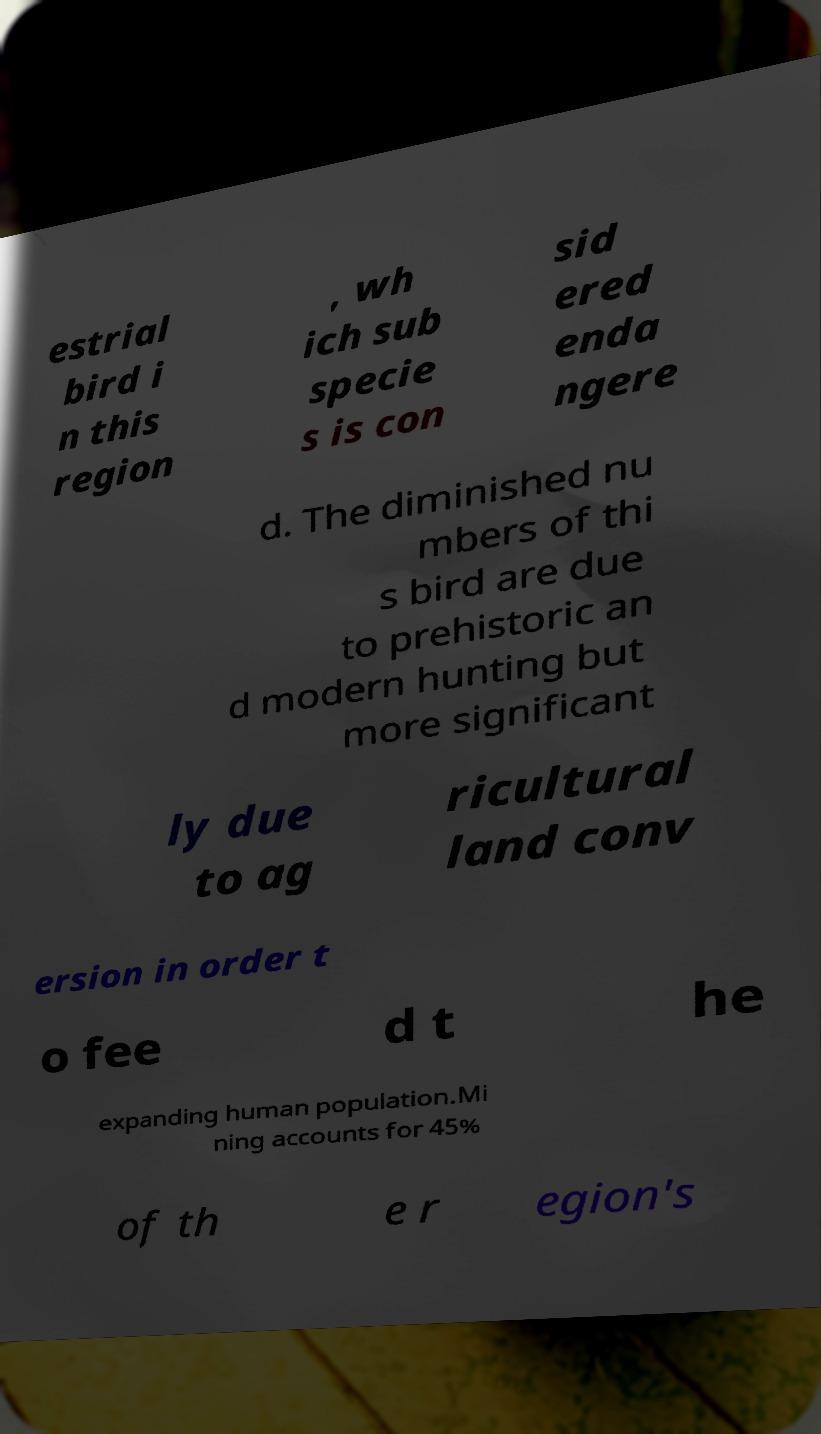Please read and relay the text visible in this image. What does it say? estrial bird i n this region , wh ich sub specie s is con sid ered enda ngere d. The diminished nu mbers of thi s bird are due to prehistoric an d modern hunting but more significant ly due to ag ricultural land conv ersion in order t o fee d t he expanding human population.Mi ning accounts for 45% of th e r egion's 